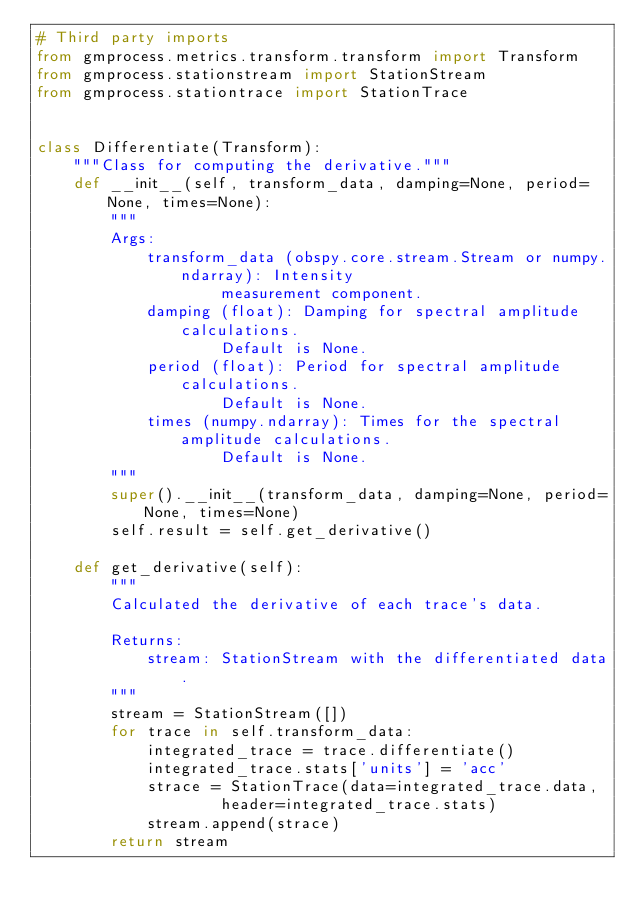<code> <loc_0><loc_0><loc_500><loc_500><_Python_># Third party imports
from gmprocess.metrics.transform.transform import Transform
from gmprocess.stationstream import StationStream
from gmprocess.stationtrace import StationTrace


class Differentiate(Transform):
    """Class for computing the derivative."""
    def __init__(self, transform_data, damping=None, period=None, times=None):
        """
        Args:
            transform_data (obspy.core.stream.Stream or numpy.ndarray): Intensity
                    measurement component.
            damping (float): Damping for spectral amplitude calculations.
                    Default is None.
            period (float): Period for spectral amplitude calculations.
                    Default is None.
            times (numpy.ndarray): Times for the spectral amplitude calculations.
                    Default is None.
        """
        super().__init__(transform_data, damping=None, period=None, times=None)
        self.result = self.get_derivative()

    def get_derivative(self):
        """
        Calculated the derivative of each trace's data.

        Returns:
            stream: StationStream with the differentiated data.
        """
        stream = StationStream([])
        for trace in self.transform_data:
            integrated_trace = trace.differentiate()
            integrated_trace.stats['units'] = 'acc'
            strace = StationTrace(data=integrated_trace.data,
                    header=integrated_trace.stats)
            stream.append(strace)
        return stream
</code> 